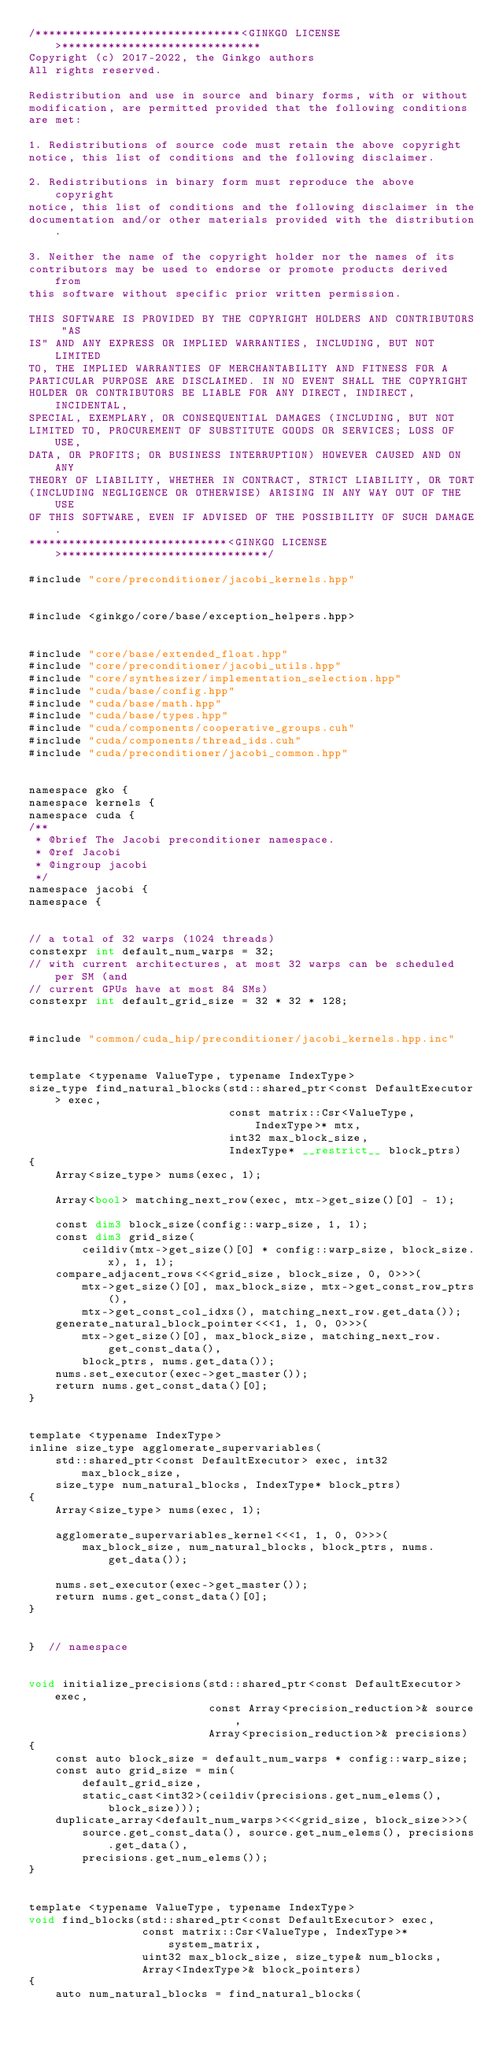<code> <loc_0><loc_0><loc_500><loc_500><_Cuda_>/*******************************<GINKGO LICENSE>******************************
Copyright (c) 2017-2022, the Ginkgo authors
All rights reserved.

Redistribution and use in source and binary forms, with or without
modification, are permitted provided that the following conditions
are met:

1. Redistributions of source code must retain the above copyright
notice, this list of conditions and the following disclaimer.

2. Redistributions in binary form must reproduce the above copyright
notice, this list of conditions and the following disclaimer in the
documentation and/or other materials provided with the distribution.

3. Neither the name of the copyright holder nor the names of its
contributors may be used to endorse or promote products derived from
this software without specific prior written permission.

THIS SOFTWARE IS PROVIDED BY THE COPYRIGHT HOLDERS AND CONTRIBUTORS "AS
IS" AND ANY EXPRESS OR IMPLIED WARRANTIES, INCLUDING, BUT NOT LIMITED
TO, THE IMPLIED WARRANTIES OF MERCHANTABILITY AND FITNESS FOR A
PARTICULAR PURPOSE ARE DISCLAIMED. IN NO EVENT SHALL THE COPYRIGHT
HOLDER OR CONTRIBUTORS BE LIABLE FOR ANY DIRECT, INDIRECT, INCIDENTAL,
SPECIAL, EXEMPLARY, OR CONSEQUENTIAL DAMAGES (INCLUDING, BUT NOT
LIMITED TO, PROCUREMENT OF SUBSTITUTE GOODS OR SERVICES; LOSS OF USE,
DATA, OR PROFITS; OR BUSINESS INTERRUPTION) HOWEVER CAUSED AND ON ANY
THEORY OF LIABILITY, WHETHER IN CONTRACT, STRICT LIABILITY, OR TORT
(INCLUDING NEGLIGENCE OR OTHERWISE) ARISING IN ANY WAY OUT OF THE USE
OF THIS SOFTWARE, EVEN IF ADVISED OF THE POSSIBILITY OF SUCH DAMAGE.
******************************<GINKGO LICENSE>*******************************/

#include "core/preconditioner/jacobi_kernels.hpp"


#include <ginkgo/core/base/exception_helpers.hpp>


#include "core/base/extended_float.hpp"
#include "core/preconditioner/jacobi_utils.hpp"
#include "core/synthesizer/implementation_selection.hpp"
#include "cuda/base/config.hpp"
#include "cuda/base/math.hpp"
#include "cuda/base/types.hpp"
#include "cuda/components/cooperative_groups.cuh"
#include "cuda/components/thread_ids.cuh"
#include "cuda/preconditioner/jacobi_common.hpp"


namespace gko {
namespace kernels {
namespace cuda {
/**
 * @brief The Jacobi preconditioner namespace.
 * @ref Jacobi
 * @ingroup jacobi
 */
namespace jacobi {
namespace {


// a total of 32 warps (1024 threads)
constexpr int default_num_warps = 32;
// with current architectures, at most 32 warps can be scheduled per SM (and
// current GPUs have at most 84 SMs)
constexpr int default_grid_size = 32 * 32 * 128;


#include "common/cuda_hip/preconditioner/jacobi_kernels.hpp.inc"


template <typename ValueType, typename IndexType>
size_type find_natural_blocks(std::shared_ptr<const DefaultExecutor> exec,
                              const matrix::Csr<ValueType, IndexType>* mtx,
                              int32 max_block_size,
                              IndexType* __restrict__ block_ptrs)
{
    Array<size_type> nums(exec, 1);

    Array<bool> matching_next_row(exec, mtx->get_size()[0] - 1);

    const dim3 block_size(config::warp_size, 1, 1);
    const dim3 grid_size(
        ceildiv(mtx->get_size()[0] * config::warp_size, block_size.x), 1, 1);
    compare_adjacent_rows<<<grid_size, block_size, 0, 0>>>(
        mtx->get_size()[0], max_block_size, mtx->get_const_row_ptrs(),
        mtx->get_const_col_idxs(), matching_next_row.get_data());
    generate_natural_block_pointer<<<1, 1, 0, 0>>>(
        mtx->get_size()[0], max_block_size, matching_next_row.get_const_data(),
        block_ptrs, nums.get_data());
    nums.set_executor(exec->get_master());
    return nums.get_const_data()[0];
}


template <typename IndexType>
inline size_type agglomerate_supervariables(
    std::shared_ptr<const DefaultExecutor> exec, int32 max_block_size,
    size_type num_natural_blocks, IndexType* block_ptrs)
{
    Array<size_type> nums(exec, 1);

    agglomerate_supervariables_kernel<<<1, 1, 0, 0>>>(
        max_block_size, num_natural_blocks, block_ptrs, nums.get_data());

    nums.set_executor(exec->get_master());
    return nums.get_const_data()[0];
}


}  // namespace


void initialize_precisions(std::shared_ptr<const DefaultExecutor> exec,
                           const Array<precision_reduction>& source,
                           Array<precision_reduction>& precisions)
{
    const auto block_size = default_num_warps * config::warp_size;
    const auto grid_size = min(
        default_grid_size,
        static_cast<int32>(ceildiv(precisions.get_num_elems(), block_size)));
    duplicate_array<default_num_warps><<<grid_size, block_size>>>(
        source.get_const_data(), source.get_num_elems(), precisions.get_data(),
        precisions.get_num_elems());
}


template <typename ValueType, typename IndexType>
void find_blocks(std::shared_ptr<const DefaultExecutor> exec,
                 const matrix::Csr<ValueType, IndexType>* system_matrix,
                 uint32 max_block_size, size_type& num_blocks,
                 Array<IndexType>& block_pointers)
{
    auto num_natural_blocks = find_natural_blocks(</code> 